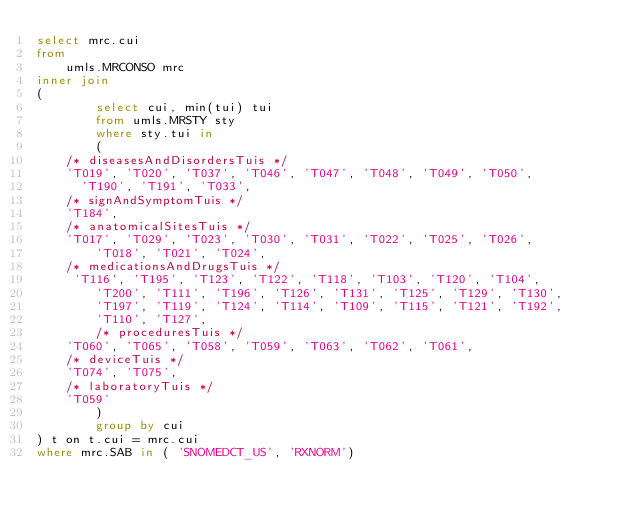Convert code to text. <code><loc_0><loc_0><loc_500><loc_500><_SQL_>select mrc.cui
from
	umls.MRCONSO mrc
inner join 
(
        select cui, min(tui) tui
        from umls.MRSTY sty
        where sty.tui in
        (
    /* diseasesAndDisordersTuis */
    'T019', 'T020', 'T037', 'T046', 'T047', 'T048', 'T049', 'T050', 
      'T190', 'T191', 'T033',
    /* signAndSymptomTuis */
    'T184',
    /* anatomicalSitesTuis */
    'T017', 'T029', 'T023', 'T030', 'T031', 'T022', 'T025', 'T026',
        'T018', 'T021', 'T024',
    /* medicationsAndDrugsTuis */
     'T116', 'T195', 'T123', 'T122', 'T118', 'T103', 'T120', 'T104',
        'T200', 'T111', 'T196', 'T126', 'T131', 'T125', 'T129', 'T130',
        'T197', 'T119', 'T124', 'T114', 'T109', 'T115', 'T121', 'T192',
        'T110', 'T127',
        /* proceduresTuis */
    'T060', 'T065', 'T058', 'T059', 'T063', 'T062', 'T061',
    /* deviceTuis */
    'T074', 'T075',
    /* laboratoryTuis */
    'T059'
        )
        group by cui
) t on t.cui = mrc.cui
where mrc.SAB in ( 'SNOMEDCT_US', 'RXNORM')</code> 